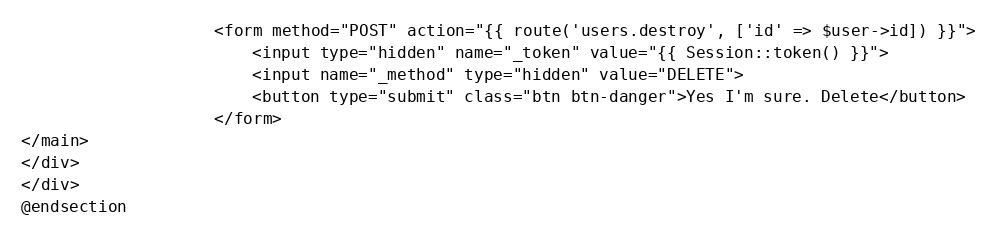<code> <loc_0><loc_0><loc_500><loc_500><_PHP_>
                    <form method="POST" action="{{ route('users.destroy', ['id' => $user->id]) }}">
                        <input type="hidden" name="_token" value="{{ Session::token() }}">
                        <input name="_method" type="hidden" value="DELETE">
                        <button type="submit" class="btn btn-danger">Yes I'm sure. Delete</button>
                    </form>
</main>
</div>
</div>
@endsection</code> 